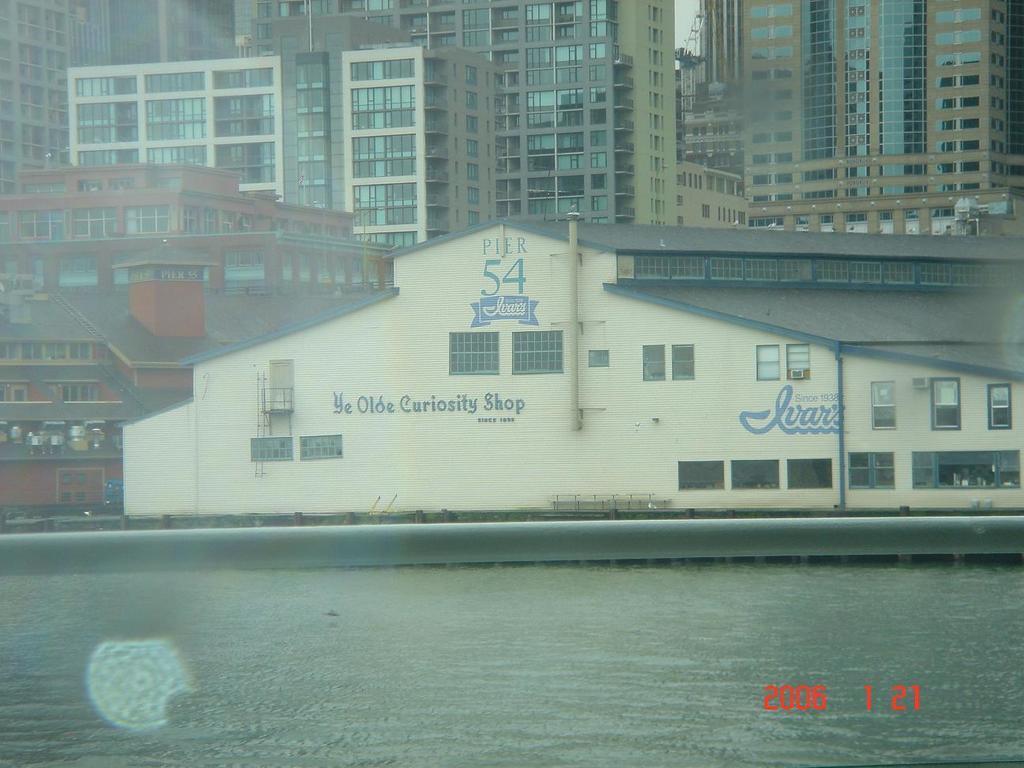Describe this image in one or two sentences. In this image we can see the water and there is a building and we can see some text on the building. We can see some buildings in the background. 